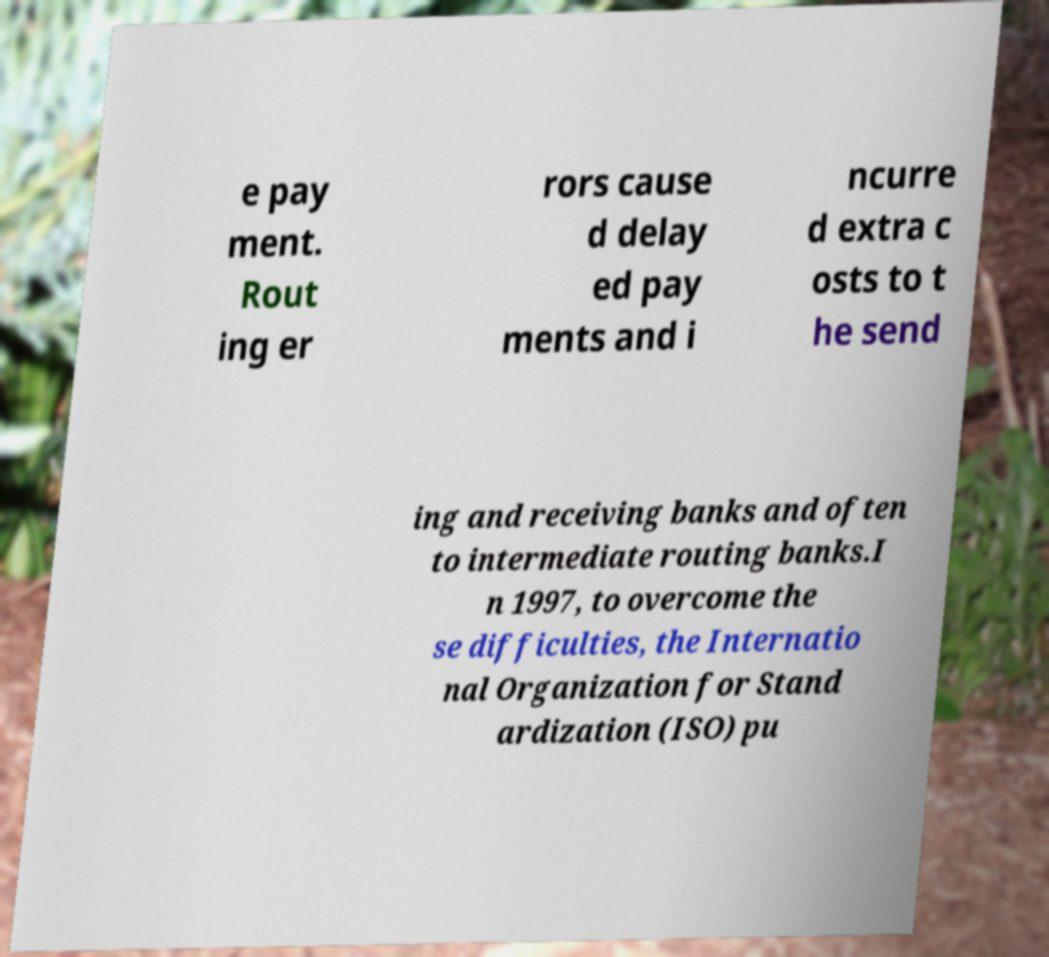I need the written content from this picture converted into text. Can you do that? e pay ment. Rout ing er rors cause d delay ed pay ments and i ncurre d extra c osts to t he send ing and receiving banks and often to intermediate routing banks.I n 1997, to overcome the se difficulties, the Internatio nal Organization for Stand ardization (ISO) pu 